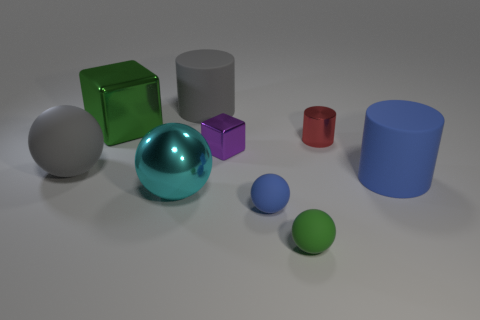Add 1 small blue things. How many objects exist? 10 Subtract all cubes. How many objects are left? 7 Add 3 cyan cylinders. How many cyan cylinders exist? 3 Subtract 1 green cubes. How many objects are left? 8 Subtract all small green matte balls. Subtract all purple spheres. How many objects are left? 8 Add 3 purple cubes. How many purple cubes are left? 4 